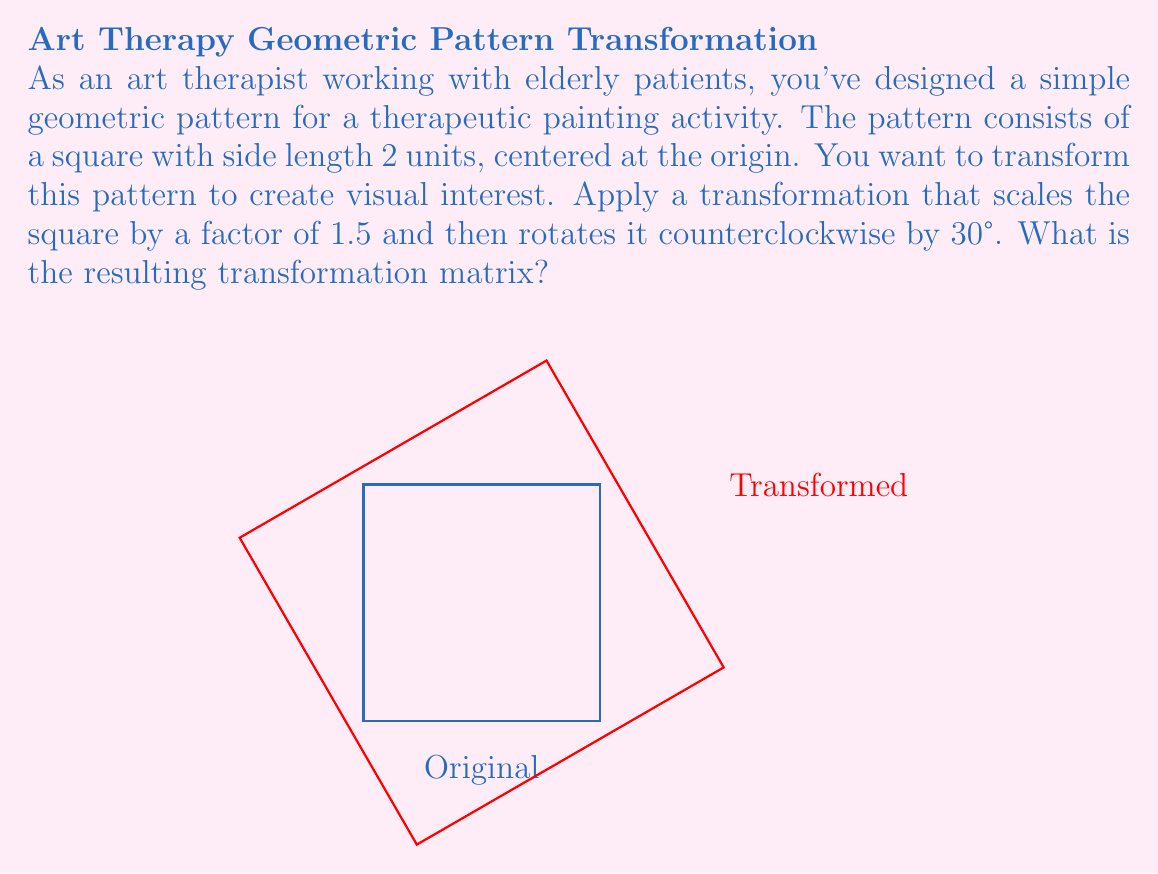Help me with this question. To solve this problem, we'll follow these steps:

1) First, let's recall the general forms of scaling and rotation matrices:

   Scaling matrix: $S = \begin{pmatrix} s_x & 0 \\ 0 & s_y \end{pmatrix}$
   
   Rotation matrix (counterclockwise by θ): $R = \begin{pmatrix} \cos θ & -\sin θ \\ \sin θ & \cos θ \end{pmatrix}$

2) In our case, we're scaling by a factor of 1.5 in both x and y directions:

   $S = \begin{pmatrix} 1.5 & 0 \\ 0 & 1.5 \end{pmatrix}$

3) We're rotating by 30° counterclockwise:

   $R = \begin{pmatrix} \cos 30° & -\sin 30° \\ \sin 30° & \cos 30° \end{pmatrix}$

4) To get the values, recall that:
   $\cos 30° = \frac{\sqrt{3}}{2}$ and $\sin 30° = \frac{1}{2}$

   So, $R = \begin{pmatrix} \frac{\sqrt{3}}{2} & -\frac{1}{2} \\ \frac{1}{2} & \frac{\sqrt{3}}{2} \end{pmatrix}$

5) The total transformation is the rotation applied after the scaling. In matrix multiplication, this is represented as $R * S$:

   $\begin{pmatrix} \frac{\sqrt{3}}{2} & -\frac{1}{2} \\ \frac{1}{2} & \frac{\sqrt{3}}{2} \end{pmatrix} * \begin{pmatrix} 1.5 & 0 \\ 0 & 1.5 \end{pmatrix}$

6) Multiplying these matrices:

   $\begin{pmatrix} \frac{\sqrt{3}}{2} * 1.5 & -\frac{1}{2} * 0 \\ \frac{1}{2} * 1.5 & \frac{\sqrt{3}}{2} * 1.5 \end{pmatrix}$

7) Simplifying:

   $\begin{pmatrix} \frac{3\sqrt{3}}{4} & 0 \\ \frac{3}{4} & \frac{3\sqrt{3}}{4} \end{pmatrix}$

This is our final transformation matrix.
Answer: $$\begin{pmatrix} \frac{3\sqrt{3}}{4} & 0 \\ \frac{3}{4} & \frac{3\sqrt{3}}{4} \end{pmatrix}$$ 